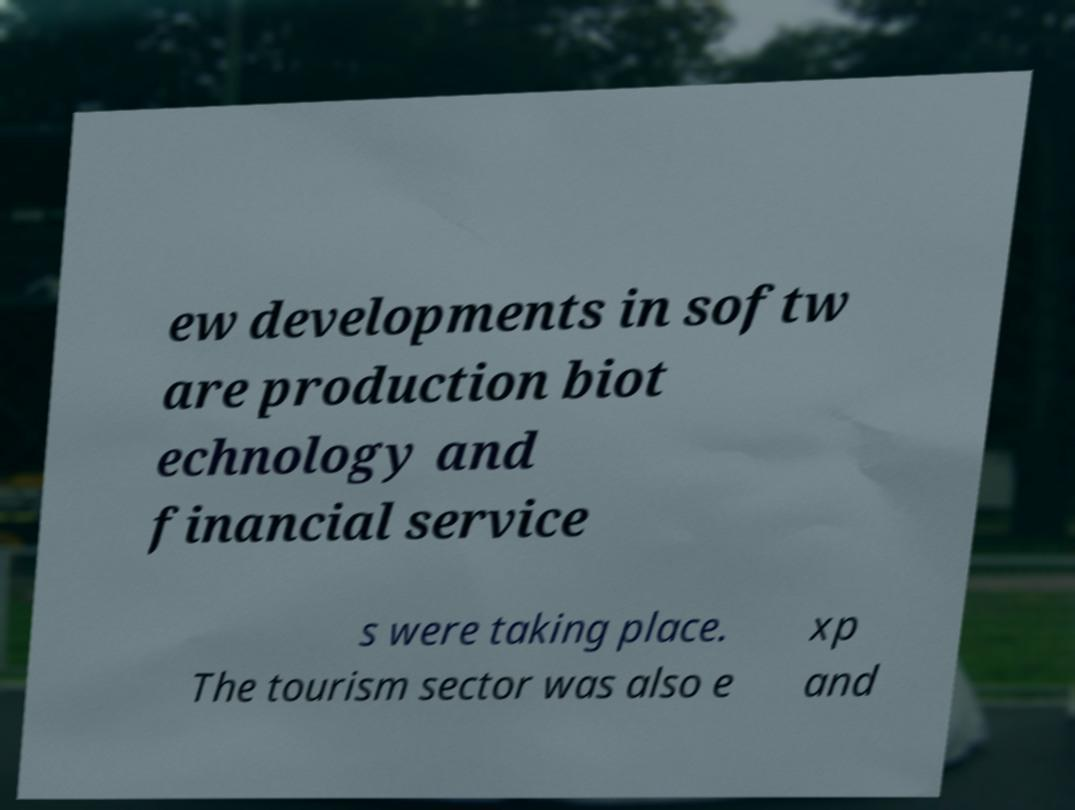What messages or text are displayed in this image? I need them in a readable, typed format. ew developments in softw are production biot echnology and financial service s were taking place. The tourism sector was also e xp and 